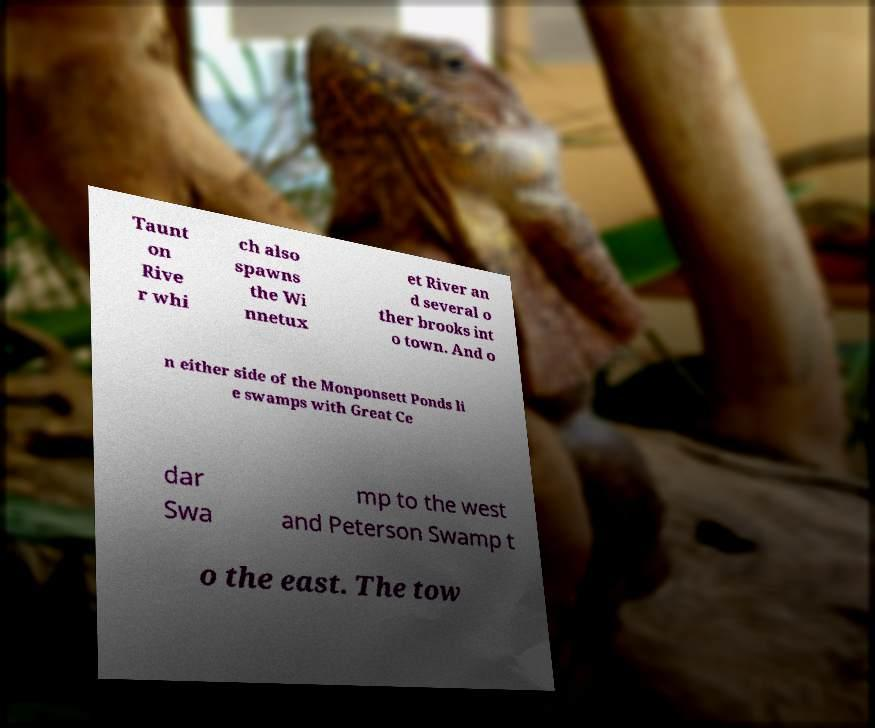For documentation purposes, I need the text within this image transcribed. Could you provide that? Taunt on Rive r whi ch also spawns the Wi nnetux et River an d several o ther brooks int o town. And o n either side of the Monponsett Ponds li e swamps with Great Ce dar Swa mp to the west and Peterson Swamp t o the east. The tow 